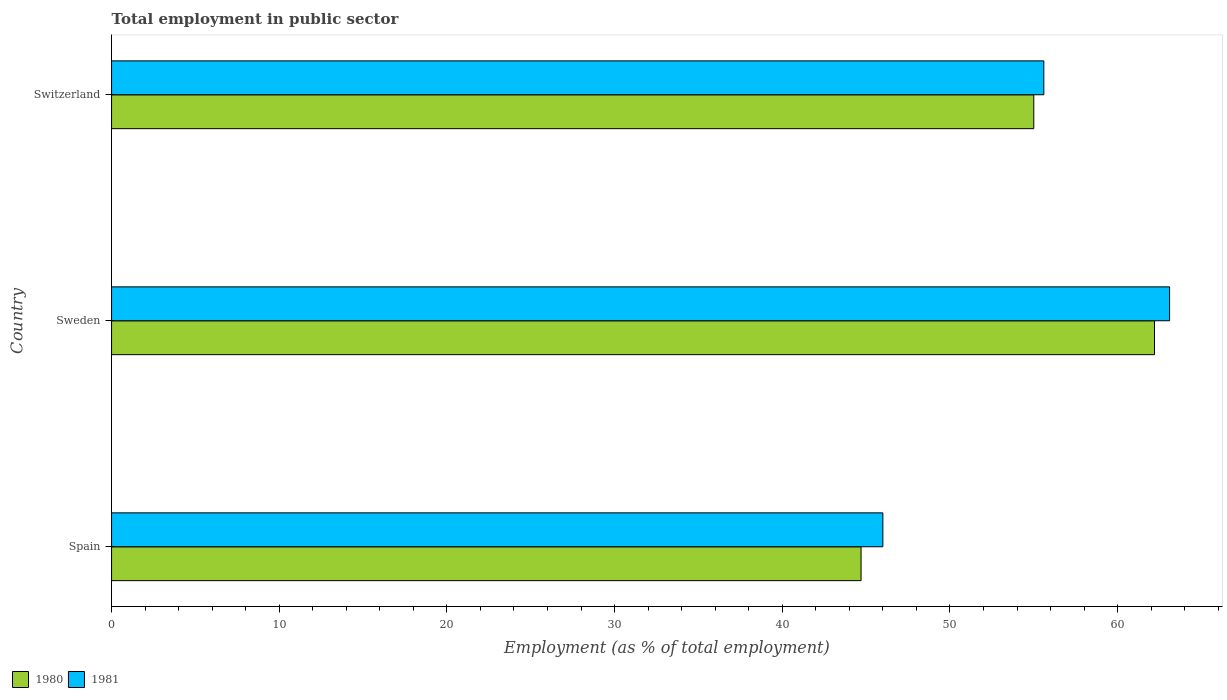How many groups of bars are there?
Your answer should be compact. 3. Are the number of bars on each tick of the Y-axis equal?
Make the answer very short. Yes. How many bars are there on the 1st tick from the bottom?
Make the answer very short. 2. What is the employment in public sector in 1981 in Switzerland?
Give a very brief answer. 55.6. Across all countries, what is the maximum employment in public sector in 1981?
Your answer should be compact. 63.1. Across all countries, what is the minimum employment in public sector in 1981?
Provide a short and direct response. 46. In which country was the employment in public sector in 1980 minimum?
Ensure brevity in your answer.  Spain. What is the total employment in public sector in 1980 in the graph?
Your response must be concise. 161.9. What is the difference between the employment in public sector in 1980 in Sweden and that in Switzerland?
Your answer should be compact. 7.2. What is the difference between the employment in public sector in 1980 in Switzerland and the employment in public sector in 1981 in Sweden?
Offer a very short reply. -8.1. What is the average employment in public sector in 1980 per country?
Your answer should be compact. 53.97. What is the difference between the employment in public sector in 1980 and employment in public sector in 1981 in Spain?
Your response must be concise. -1.3. In how many countries, is the employment in public sector in 1980 greater than 32 %?
Ensure brevity in your answer.  3. What is the ratio of the employment in public sector in 1980 in Spain to that in Sweden?
Ensure brevity in your answer.  0.72. What is the difference between the highest and the second highest employment in public sector in 1980?
Provide a succinct answer. 7.2. What is the difference between the highest and the lowest employment in public sector in 1980?
Offer a very short reply. 17.5. In how many countries, is the employment in public sector in 1980 greater than the average employment in public sector in 1980 taken over all countries?
Your answer should be very brief. 2. What does the 2nd bar from the top in Spain represents?
Give a very brief answer. 1980. How many bars are there?
Your answer should be very brief. 6. What is the difference between two consecutive major ticks on the X-axis?
Your response must be concise. 10. Does the graph contain any zero values?
Your answer should be compact. No. Does the graph contain grids?
Your answer should be compact. No. Where does the legend appear in the graph?
Provide a succinct answer. Bottom left. How are the legend labels stacked?
Keep it short and to the point. Horizontal. What is the title of the graph?
Provide a short and direct response. Total employment in public sector. What is the label or title of the X-axis?
Keep it short and to the point. Employment (as % of total employment). What is the Employment (as % of total employment) in 1980 in Spain?
Provide a succinct answer. 44.7. What is the Employment (as % of total employment) in 1981 in Spain?
Keep it short and to the point. 46. What is the Employment (as % of total employment) of 1980 in Sweden?
Provide a short and direct response. 62.2. What is the Employment (as % of total employment) in 1981 in Sweden?
Give a very brief answer. 63.1. What is the Employment (as % of total employment) in 1981 in Switzerland?
Keep it short and to the point. 55.6. Across all countries, what is the maximum Employment (as % of total employment) in 1980?
Your answer should be compact. 62.2. Across all countries, what is the maximum Employment (as % of total employment) in 1981?
Your answer should be compact. 63.1. Across all countries, what is the minimum Employment (as % of total employment) of 1980?
Make the answer very short. 44.7. Across all countries, what is the minimum Employment (as % of total employment) of 1981?
Give a very brief answer. 46. What is the total Employment (as % of total employment) of 1980 in the graph?
Give a very brief answer. 161.9. What is the total Employment (as % of total employment) of 1981 in the graph?
Offer a terse response. 164.7. What is the difference between the Employment (as % of total employment) in 1980 in Spain and that in Sweden?
Provide a short and direct response. -17.5. What is the difference between the Employment (as % of total employment) of 1981 in Spain and that in Sweden?
Make the answer very short. -17.1. What is the difference between the Employment (as % of total employment) of 1981 in Spain and that in Switzerland?
Make the answer very short. -9.6. What is the difference between the Employment (as % of total employment) of 1980 in Sweden and that in Switzerland?
Give a very brief answer. 7.2. What is the difference between the Employment (as % of total employment) in 1981 in Sweden and that in Switzerland?
Offer a terse response. 7.5. What is the difference between the Employment (as % of total employment) of 1980 in Spain and the Employment (as % of total employment) of 1981 in Sweden?
Your answer should be compact. -18.4. What is the average Employment (as % of total employment) in 1980 per country?
Make the answer very short. 53.97. What is the average Employment (as % of total employment) in 1981 per country?
Offer a very short reply. 54.9. What is the difference between the Employment (as % of total employment) in 1980 and Employment (as % of total employment) in 1981 in Spain?
Your answer should be very brief. -1.3. What is the difference between the Employment (as % of total employment) in 1980 and Employment (as % of total employment) in 1981 in Switzerland?
Offer a terse response. -0.6. What is the ratio of the Employment (as % of total employment) of 1980 in Spain to that in Sweden?
Ensure brevity in your answer.  0.72. What is the ratio of the Employment (as % of total employment) in 1981 in Spain to that in Sweden?
Your answer should be very brief. 0.73. What is the ratio of the Employment (as % of total employment) in 1980 in Spain to that in Switzerland?
Give a very brief answer. 0.81. What is the ratio of the Employment (as % of total employment) in 1981 in Spain to that in Switzerland?
Keep it short and to the point. 0.83. What is the ratio of the Employment (as % of total employment) in 1980 in Sweden to that in Switzerland?
Provide a succinct answer. 1.13. What is the ratio of the Employment (as % of total employment) in 1981 in Sweden to that in Switzerland?
Offer a terse response. 1.13. What is the difference between the highest and the second highest Employment (as % of total employment) in 1980?
Keep it short and to the point. 7.2. What is the difference between the highest and the second highest Employment (as % of total employment) of 1981?
Your response must be concise. 7.5. What is the difference between the highest and the lowest Employment (as % of total employment) of 1981?
Your answer should be very brief. 17.1. 